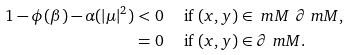<formula> <loc_0><loc_0><loc_500><loc_500>1 - \phi ( \beta ) - \alpha ( | \mu | ^ { 2 } ) & < 0 \quad \text { if } ( x , y ) \in \ m M \ \partial \ m M , \\ & = 0 \quad \text { if } ( x , y ) \in \partial \ m M .</formula> 